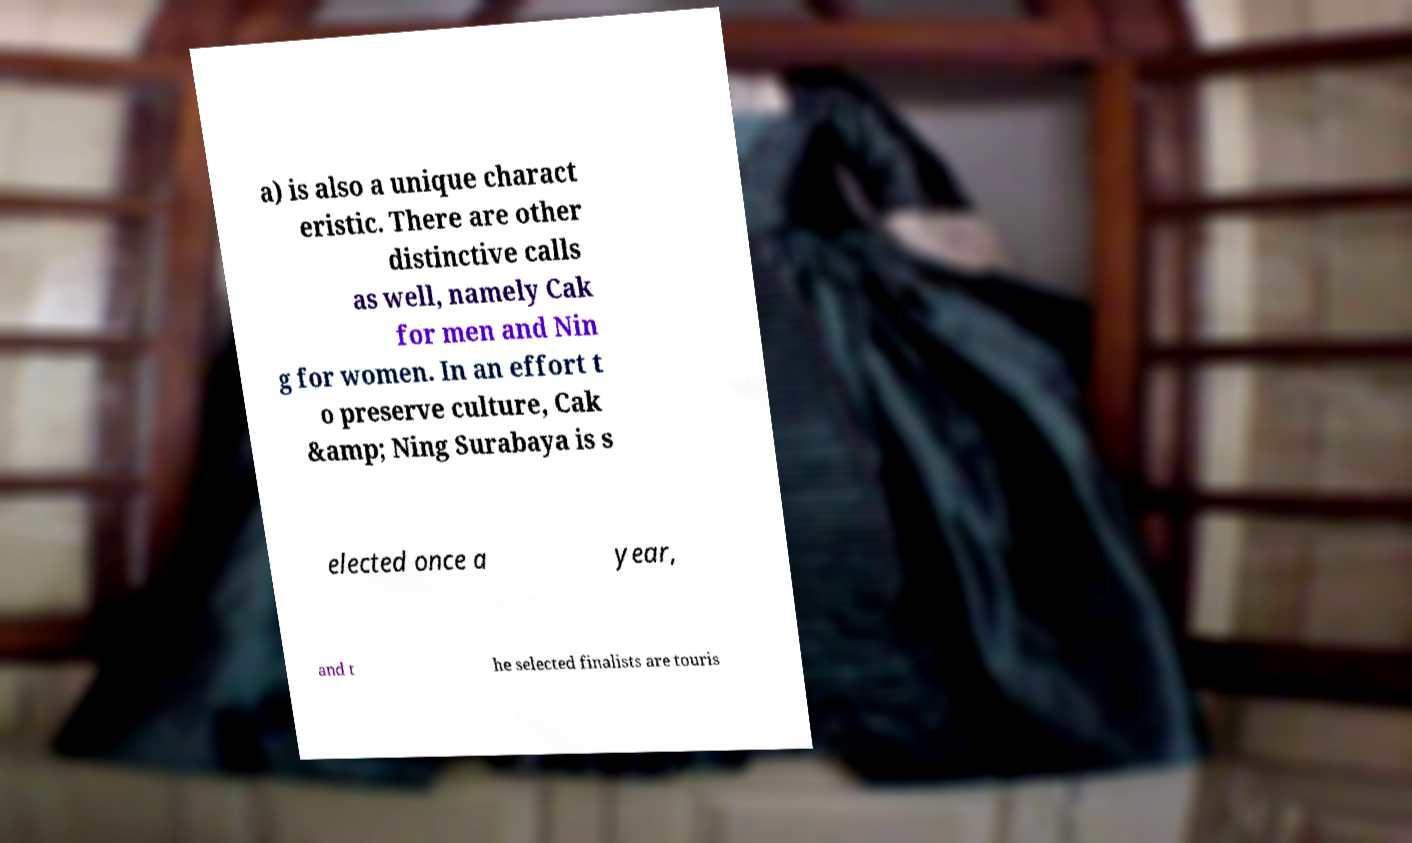Please identify and transcribe the text found in this image. a) is also a unique charact eristic. There are other distinctive calls as well, namely Cak for men and Nin g for women. In an effort t o preserve culture, Cak &amp; Ning Surabaya is s elected once a year, and t he selected finalists are touris 